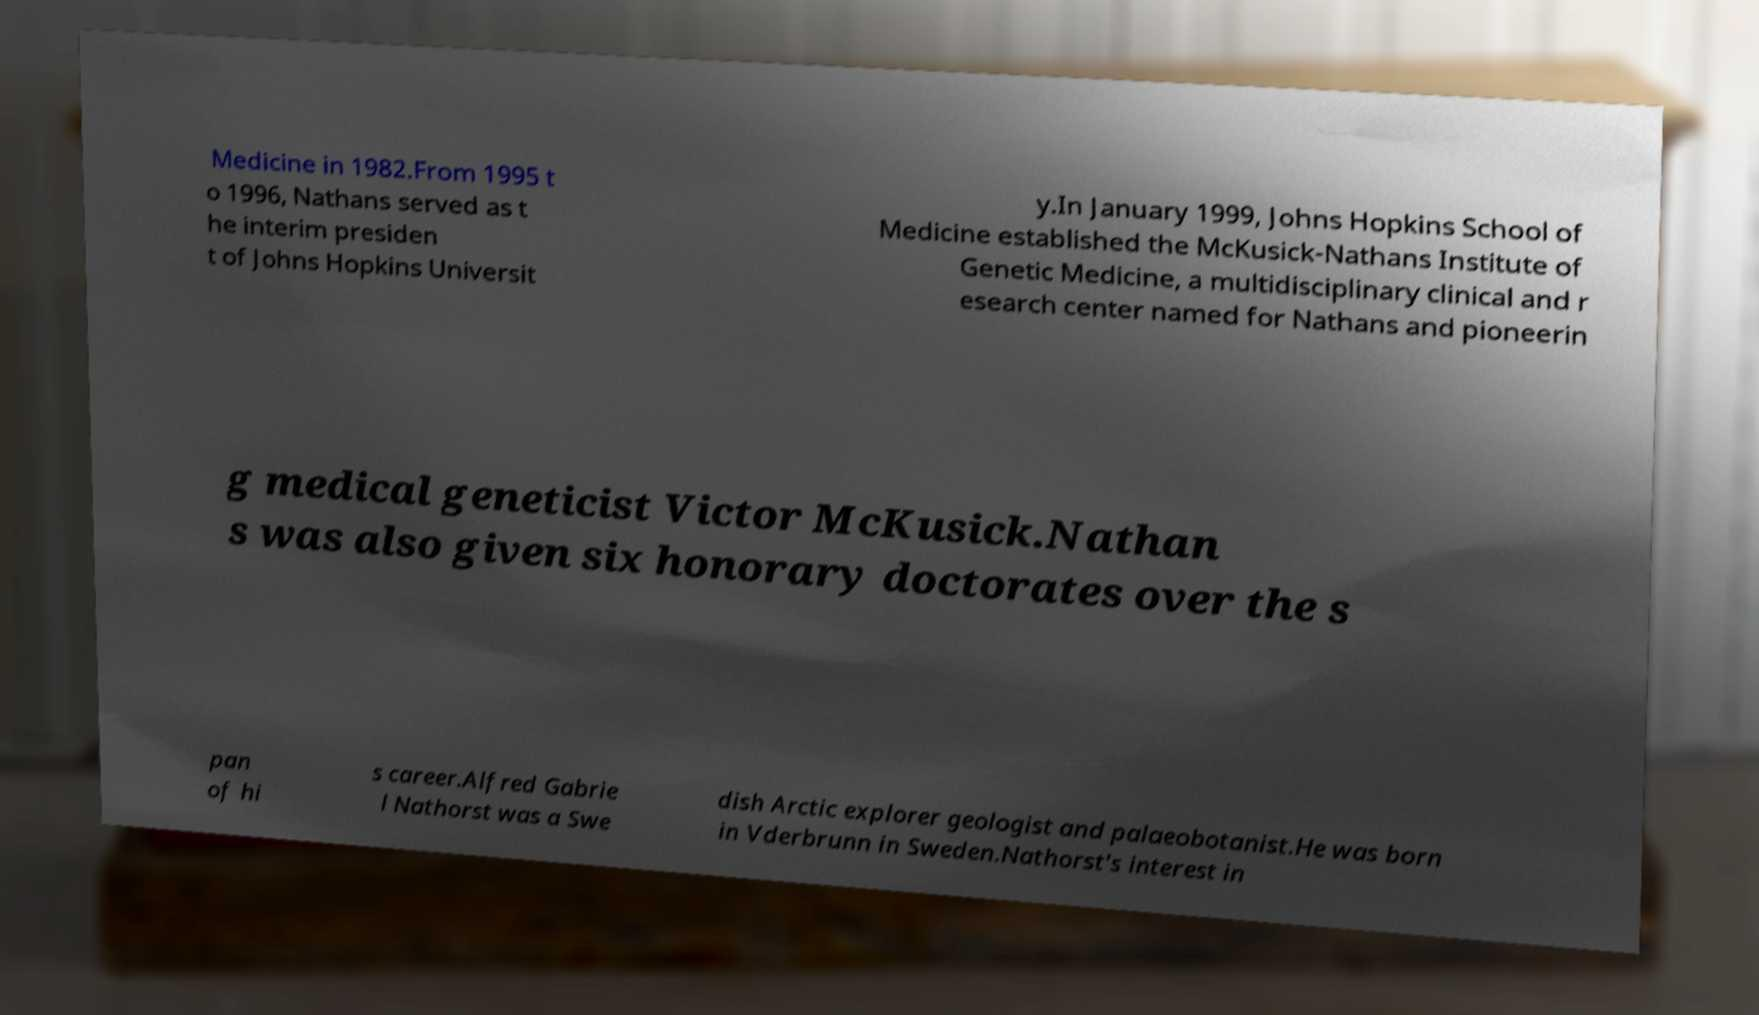For documentation purposes, I need the text within this image transcribed. Could you provide that? Medicine in 1982.From 1995 t o 1996, Nathans served as t he interim presiden t of Johns Hopkins Universit y.In January 1999, Johns Hopkins School of Medicine established the McKusick-Nathans Institute of Genetic Medicine, a multidisciplinary clinical and r esearch center named for Nathans and pioneerin g medical geneticist Victor McKusick.Nathan s was also given six honorary doctorates over the s pan of hi s career.Alfred Gabrie l Nathorst was a Swe dish Arctic explorer geologist and palaeobotanist.He was born in Vderbrunn in Sweden.Nathorst's interest in 